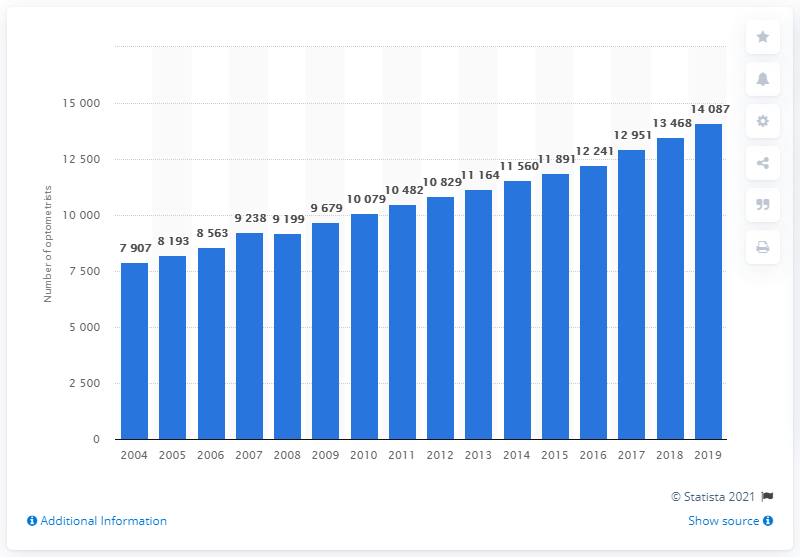List a handful of essential elements in this visual. There were 14,087 optometrists in England in 2018. The number of optometrists in England increased in 2004. In 2008, the number of female optometrists increased. 